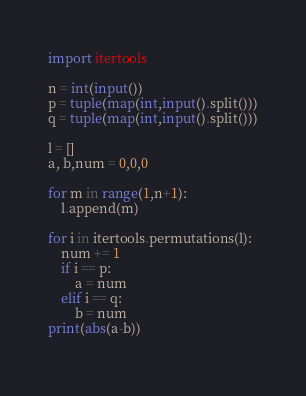Convert code to text. <code><loc_0><loc_0><loc_500><loc_500><_Python_>import itertools

n = int(input())
p = tuple(map(int,input().split()))
q = tuple(map(int,input().split()))

l = []
a, b,num = 0,0,0

for m in range(1,n+1):
	l.append(m)

for i in itertools.permutations(l):
	num += 1
	if i == p:
		a = num
	elif i == q:
		b = num
print(abs(a-b))
	</code> 